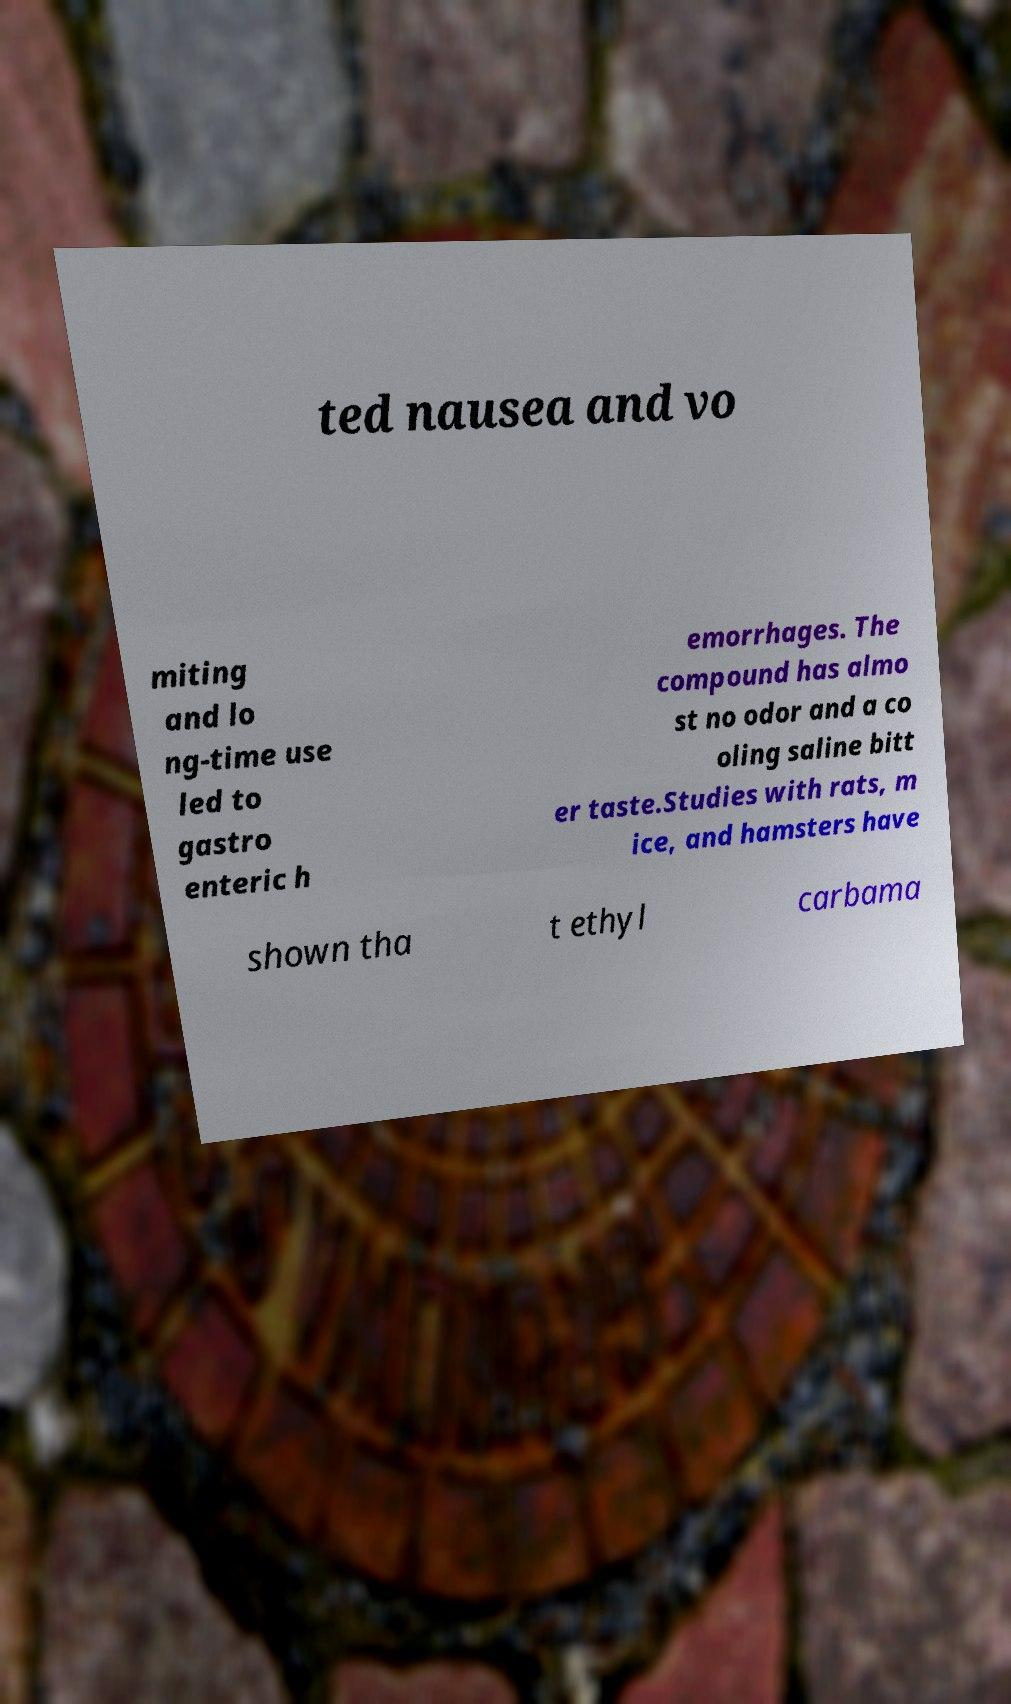Can you accurately transcribe the text from the provided image for me? ted nausea and vo miting and lo ng-time use led to gastro enteric h emorrhages. The compound has almo st no odor and a co oling saline bitt er taste.Studies with rats, m ice, and hamsters have shown tha t ethyl carbama 